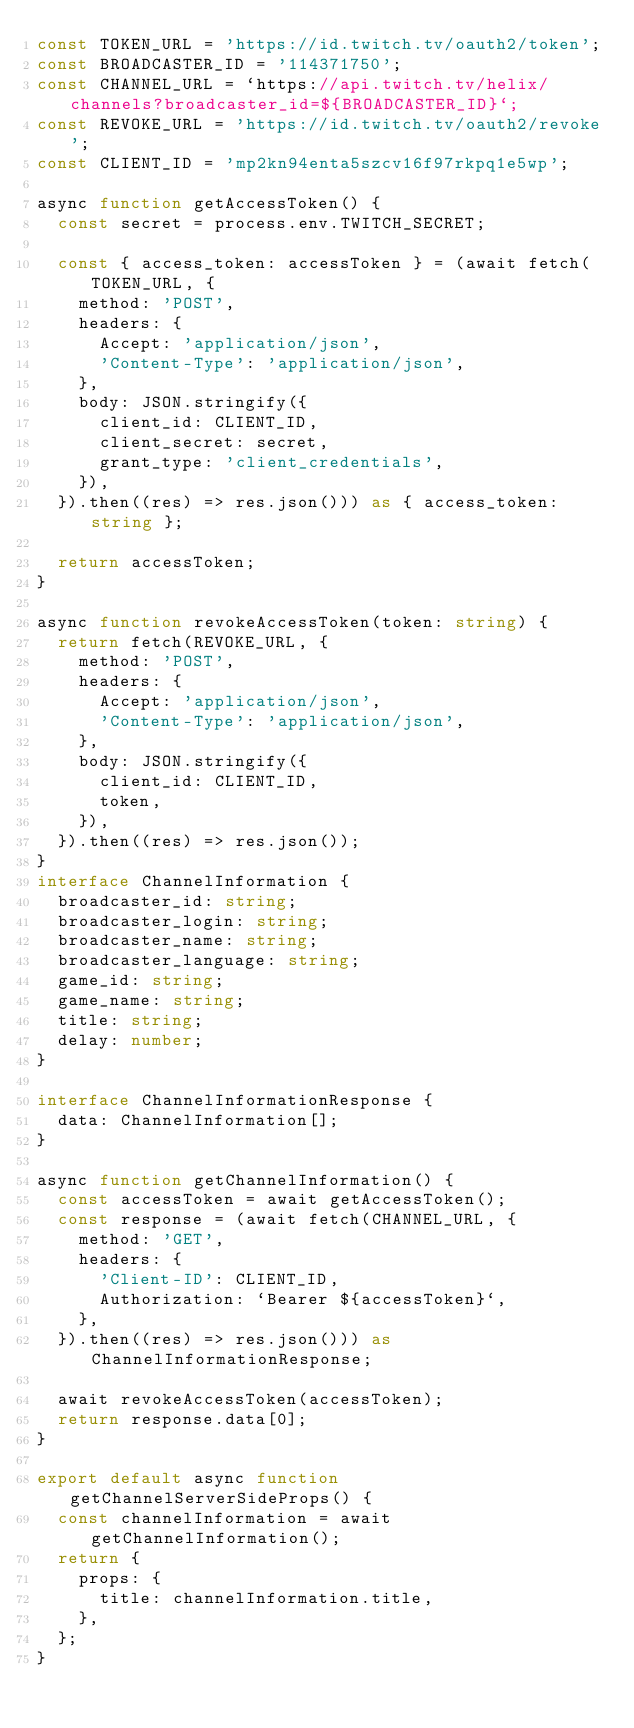Convert code to text. <code><loc_0><loc_0><loc_500><loc_500><_TypeScript_>const TOKEN_URL = 'https://id.twitch.tv/oauth2/token';
const BROADCASTER_ID = '114371750';
const CHANNEL_URL = `https://api.twitch.tv/helix/channels?broadcaster_id=${BROADCASTER_ID}`;
const REVOKE_URL = 'https://id.twitch.tv/oauth2/revoke';
const CLIENT_ID = 'mp2kn94enta5szcv16f97rkpq1e5wp';

async function getAccessToken() {
  const secret = process.env.TWITCH_SECRET;

  const { access_token: accessToken } = (await fetch(TOKEN_URL, {
    method: 'POST',
    headers: {
      Accept: 'application/json',
      'Content-Type': 'application/json',
    },
    body: JSON.stringify({
      client_id: CLIENT_ID,
      client_secret: secret,
      grant_type: 'client_credentials',
    }),
  }).then((res) => res.json())) as { access_token: string };

  return accessToken;
}

async function revokeAccessToken(token: string) {
  return fetch(REVOKE_URL, {
    method: 'POST',
    headers: {
      Accept: 'application/json',
      'Content-Type': 'application/json',
    },
    body: JSON.stringify({
      client_id: CLIENT_ID,
      token,
    }),
  }).then((res) => res.json());
}
interface ChannelInformation {
  broadcaster_id: string;
  broadcaster_login: string;
  broadcaster_name: string;
  broadcaster_language: string;
  game_id: string;
  game_name: string;
  title: string;
  delay: number;
}

interface ChannelInformationResponse {
  data: ChannelInformation[];
}

async function getChannelInformation() {
  const accessToken = await getAccessToken();
  const response = (await fetch(CHANNEL_URL, {
    method: 'GET',
    headers: {
      'Client-ID': CLIENT_ID,
      Authorization: `Bearer ${accessToken}`,
    },
  }).then((res) => res.json())) as ChannelInformationResponse;

  await revokeAccessToken(accessToken);
  return response.data[0];
}

export default async function getChannelServerSideProps() {
  const channelInformation = await getChannelInformation();
  return {
    props: {
      title: channelInformation.title,
    },
  };
}
</code> 